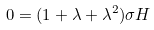Convert formula to latex. <formula><loc_0><loc_0><loc_500><loc_500>0 = ( 1 + \lambda + \lambda ^ { 2 } ) \sigma H</formula> 